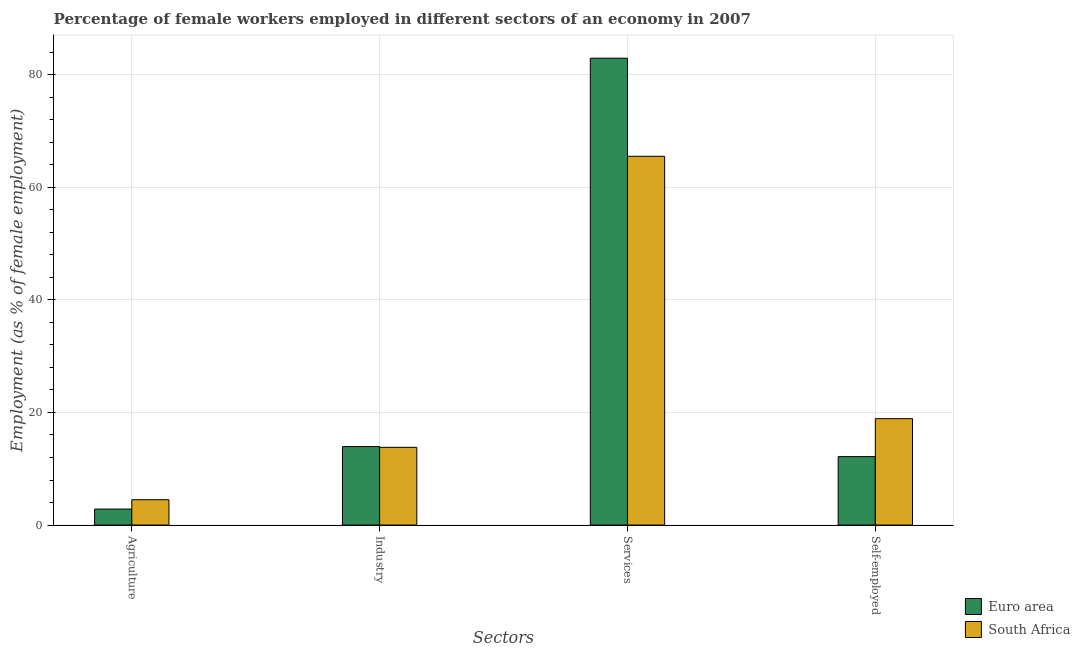Are the number of bars per tick equal to the number of legend labels?
Offer a terse response. Yes. Are the number of bars on each tick of the X-axis equal?
Your answer should be compact. Yes. How many bars are there on the 2nd tick from the left?
Your answer should be very brief. 2. What is the label of the 3rd group of bars from the left?
Your response must be concise. Services. What is the percentage of female workers in services in South Africa?
Your response must be concise. 65.5. Across all countries, what is the maximum percentage of self employed female workers?
Your answer should be very brief. 18.9. Across all countries, what is the minimum percentage of female workers in services?
Ensure brevity in your answer.  65.5. In which country was the percentage of female workers in agriculture maximum?
Provide a succinct answer. South Africa. In which country was the percentage of female workers in industry minimum?
Give a very brief answer. South Africa. What is the total percentage of self employed female workers in the graph?
Offer a terse response. 31.06. What is the difference between the percentage of female workers in agriculture in South Africa and that in Euro area?
Provide a succinct answer. 1.66. What is the difference between the percentage of self employed female workers in South Africa and the percentage of female workers in industry in Euro area?
Your answer should be compact. 4.96. What is the average percentage of female workers in agriculture per country?
Make the answer very short. 3.67. What is the difference between the percentage of female workers in industry and percentage of female workers in services in South Africa?
Your answer should be compact. -51.7. What is the ratio of the percentage of female workers in industry in South Africa to that in Euro area?
Provide a short and direct response. 0.99. Is the difference between the percentage of self employed female workers in South Africa and Euro area greater than the difference between the percentage of female workers in agriculture in South Africa and Euro area?
Make the answer very short. Yes. What is the difference between the highest and the second highest percentage of female workers in services?
Make the answer very short. 17.42. What is the difference between the highest and the lowest percentage of female workers in industry?
Keep it short and to the point. 0.14. What does the 2nd bar from the left in Services represents?
Your answer should be compact. South Africa. What does the 1st bar from the right in Self-employed represents?
Provide a short and direct response. South Africa. Are all the bars in the graph horizontal?
Keep it short and to the point. No. How many countries are there in the graph?
Provide a succinct answer. 2. What is the difference between two consecutive major ticks on the Y-axis?
Your response must be concise. 20. Are the values on the major ticks of Y-axis written in scientific E-notation?
Ensure brevity in your answer.  No. Does the graph contain any zero values?
Your response must be concise. No. Where does the legend appear in the graph?
Your answer should be compact. Bottom right. What is the title of the graph?
Provide a short and direct response. Percentage of female workers employed in different sectors of an economy in 2007. What is the label or title of the X-axis?
Ensure brevity in your answer.  Sectors. What is the label or title of the Y-axis?
Your answer should be very brief. Employment (as % of female employment). What is the Employment (as % of female employment) of Euro area in Agriculture?
Provide a short and direct response. 2.84. What is the Employment (as % of female employment) of Euro area in Industry?
Give a very brief answer. 13.94. What is the Employment (as % of female employment) in South Africa in Industry?
Keep it short and to the point. 13.8. What is the Employment (as % of female employment) in Euro area in Services?
Keep it short and to the point. 82.92. What is the Employment (as % of female employment) in South Africa in Services?
Offer a very short reply. 65.5. What is the Employment (as % of female employment) in Euro area in Self-employed?
Provide a short and direct response. 12.16. What is the Employment (as % of female employment) in South Africa in Self-employed?
Offer a terse response. 18.9. Across all Sectors, what is the maximum Employment (as % of female employment) of Euro area?
Keep it short and to the point. 82.92. Across all Sectors, what is the maximum Employment (as % of female employment) in South Africa?
Give a very brief answer. 65.5. Across all Sectors, what is the minimum Employment (as % of female employment) of Euro area?
Give a very brief answer. 2.84. Across all Sectors, what is the minimum Employment (as % of female employment) in South Africa?
Your answer should be compact. 4.5. What is the total Employment (as % of female employment) of Euro area in the graph?
Give a very brief answer. 111.87. What is the total Employment (as % of female employment) in South Africa in the graph?
Give a very brief answer. 102.7. What is the difference between the Employment (as % of female employment) of Euro area in Agriculture and that in Industry?
Offer a terse response. -11.1. What is the difference between the Employment (as % of female employment) of South Africa in Agriculture and that in Industry?
Your answer should be compact. -9.3. What is the difference between the Employment (as % of female employment) of Euro area in Agriculture and that in Services?
Your answer should be very brief. -80.08. What is the difference between the Employment (as % of female employment) of South Africa in Agriculture and that in Services?
Keep it short and to the point. -61. What is the difference between the Employment (as % of female employment) in Euro area in Agriculture and that in Self-employed?
Provide a succinct answer. -9.31. What is the difference between the Employment (as % of female employment) of South Africa in Agriculture and that in Self-employed?
Provide a succinct answer. -14.4. What is the difference between the Employment (as % of female employment) in Euro area in Industry and that in Services?
Your answer should be very brief. -68.98. What is the difference between the Employment (as % of female employment) in South Africa in Industry and that in Services?
Ensure brevity in your answer.  -51.7. What is the difference between the Employment (as % of female employment) of Euro area in Industry and that in Self-employed?
Offer a very short reply. 1.78. What is the difference between the Employment (as % of female employment) in South Africa in Industry and that in Self-employed?
Provide a succinct answer. -5.1. What is the difference between the Employment (as % of female employment) of Euro area in Services and that in Self-employed?
Your answer should be very brief. 70.77. What is the difference between the Employment (as % of female employment) of South Africa in Services and that in Self-employed?
Provide a short and direct response. 46.6. What is the difference between the Employment (as % of female employment) of Euro area in Agriculture and the Employment (as % of female employment) of South Africa in Industry?
Keep it short and to the point. -10.96. What is the difference between the Employment (as % of female employment) of Euro area in Agriculture and the Employment (as % of female employment) of South Africa in Services?
Your answer should be compact. -62.66. What is the difference between the Employment (as % of female employment) in Euro area in Agriculture and the Employment (as % of female employment) in South Africa in Self-employed?
Your answer should be very brief. -16.06. What is the difference between the Employment (as % of female employment) of Euro area in Industry and the Employment (as % of female employment) of South Africa in Services?
Provide a short and direct response. -51.56. What is the difference between the Employment (as % of female employment) of Euro area in Industry and the Employment (as % of female employment) of South Africa in Self-employed?
Provide a succinct answer. -4.96. What is the difference between the Employment (as % of female employment) in Euro area in Services and the Employment (as % of female employment) in South Africa in Self-employed?
Your answer should be compact. 64.02. What is the average Employment (as % of female employment) of Euro area per Sectors?
Keep it short and to the point. 27.97. What is the average Employment (as % of female employment) of South Africa per Sectors?
Your answer should be compact. 25.68. What is the difference between the Employment (as % of female employment) in Euro area and Employment (as % of female employment) in South Africa in Agriculture?
Ensure brevity in your answer.  -1.66. What is the difference between the Employment (as % of female employment) in Euro area and Employment (as % of female employment) in South Africa in Industry?
Offer a very short reply. 0.14. What is the difference between the Employment (as % of female employment) in Euro area and Employment (as % of female employment) in South Africa in Services?
Provide a succinct answer. 17.42. What is the difference between the Employment (as % of female employment) of Euro area and Employment (as % of female employment) of South Africa in Self-employed?
Your answer should be compact. -6.74. What is the ratio of the Employment (as % of female employment) of Euro area in Agriculture to that in Industry?
Your answer should be very brief. 0.2. What is the ratio of the Employment (as % of female employment) in South Africa in Agriculture to that in Industry?
Your answer should be very brief. 0.33. What is the ratio of the Employment (as % of female employment) in Euro area in Agriculture to that in Services?
Your response must be concise. 0.03. What is the ratio of the Employment (as % of female employment) of South Africa in Agriculture to that in Services?
Offer a terse response. 0.07. What is the ratio of the Employment (as % of female employment) in Euro area in Agriculture to that in Self-employed?
Give a very brief answer. 0.23. What is the ratio of the Employment (as % of female employment) in South Africa in Agriculture to that in Self-employed?
Your response must be concise. 0.24. What is the ratio of the Employment (as % of female employment) in Euro area in Industry to that in Services?
Make the answer very short. 0.17. What is the ratio of the Employment (as % of female employment) in South Africa in Industry to that in Services?
Offer a very short reply. 0.21. What is the ratio of the Employment (as % of female employment) of Euro area in Industry to that in Self-employed?
Provide a short and direct response. 1.15. What is the ratio of the Employment (as % of female employment) of South Africa in Industry to that in Self-employed?
Provide a short and direct response. 0.73. What is the ratio of the Employment (as % of female employment) in Euro area in Services to that in Self-employed?
Provide a short and direct response. 6.82. What is the ratio of the Employment (as % of female employment) in South Africa in Services to that in Self-employed?
Your answer should be very brief. 3.47. What is the difference between the highest and the second highest Employment (as % of female employment) of Euro area?
Your response must be concise. 68.98. What is the difference between the highest and the second highest Employment (as % of female employment) in South Africa?
Ensure brevity in your answer.  46.6. What is the difference between the highest and the lowest Employment (as % of female employment) in Euro area?
Your answer should be compact. 80.08. 